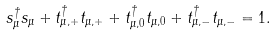<formula> <loc_0><loc_0><loc_500><loc_500>s _ { \mu } ^ { \dagger } s _ { \mu } + t _ { \mu , + } ^ { \dagger } t _ { \mu , + } + t _ { \mu , 0 } ^ { \dagger } t _ { \mu , 0 } + t _ { \mu , - } ^ { \dagger } t _ { \mu , - } = 1 .</formula> 